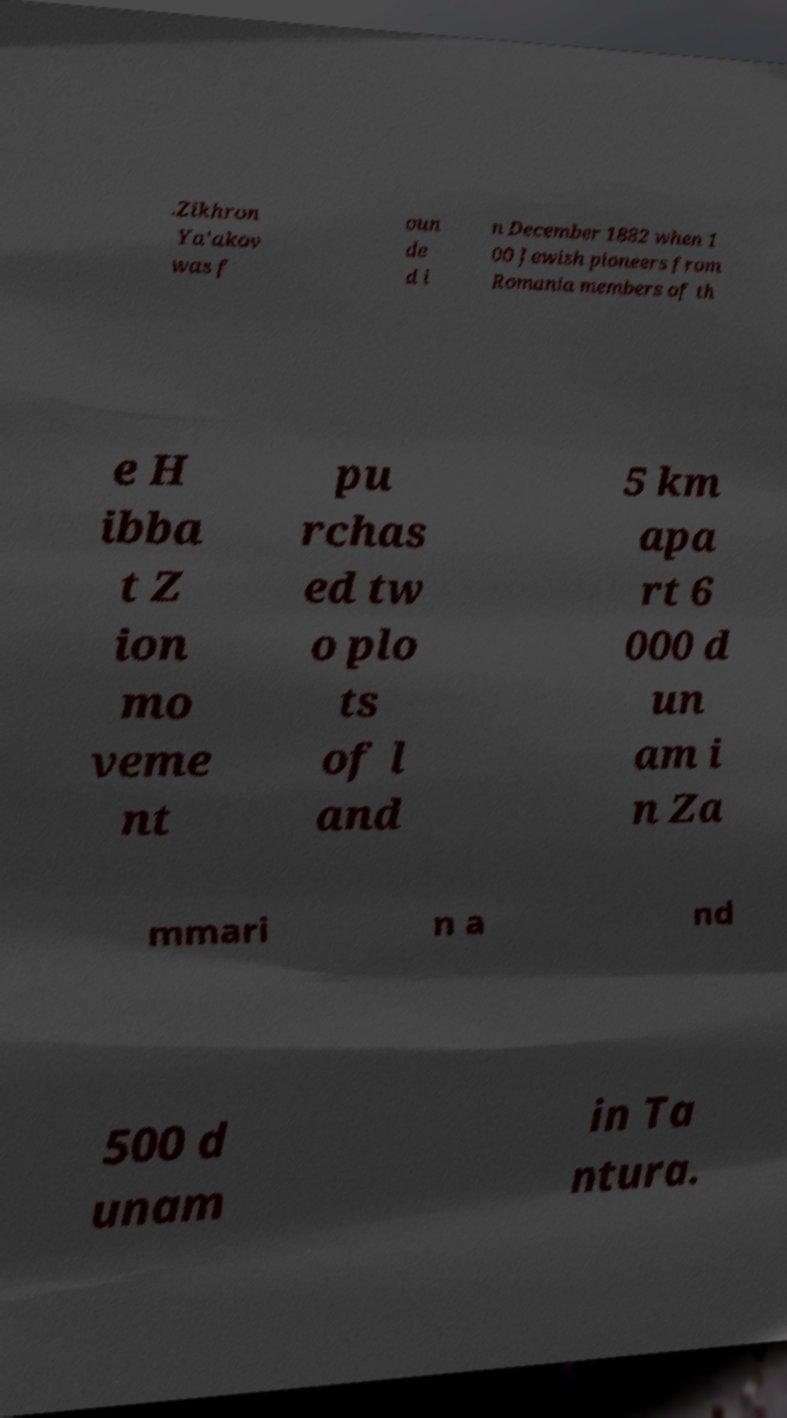Can you accurately transcribe the text from the provided image for me? .Zikhron Ya'akov was f oun de d i n December 1882 when 1 00 Jewish pioneers from Romania members of th e H ibba t Z ion mo veme nt pu rchas ed tw o plo ts of l and 5 km apa rt 6 000 d un am i n Za mmari n a nd 500 d unam in Ta ntura. 